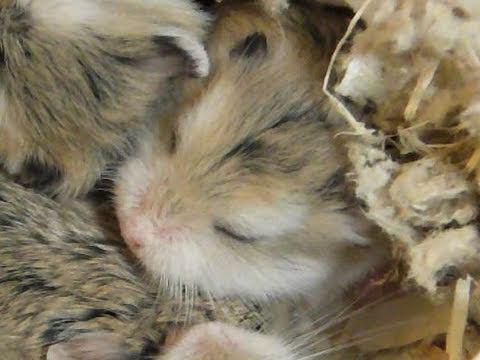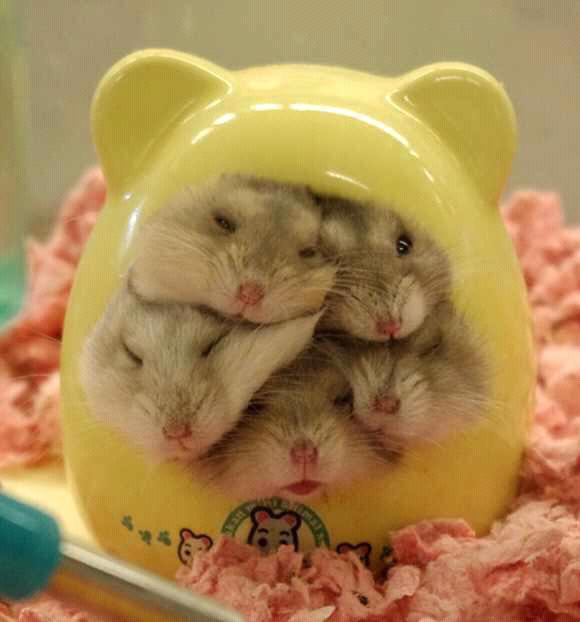The first image is the image on the left, the second image is the image on the right. Assess this claim about the two images: "The right image contains at least one rodent standing on a blue cloth.". Correct or not? Answer yes or no. No. 